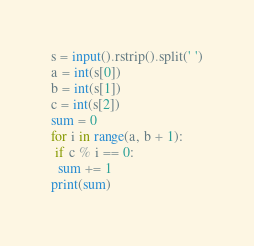<code> <loc_0><loc_0><loc_500><loc_500><_Python_>s = input().rstrip().split(' ')
a = int(s[0])
b = int(s[1])
c = int(s[2])
sum = 0
for i in range(a, b + 1):
 if c % i == 0:
  sum += 1
print(sum)
</code> 